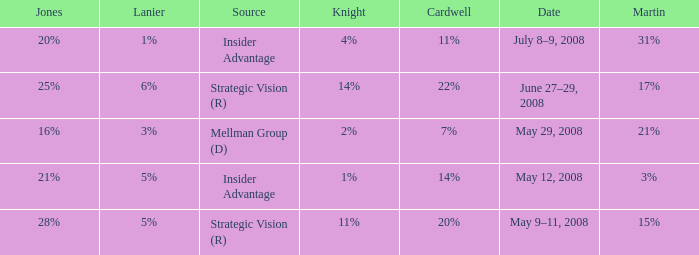What source has a cardwell of 20%? Strategic Vision (R). 